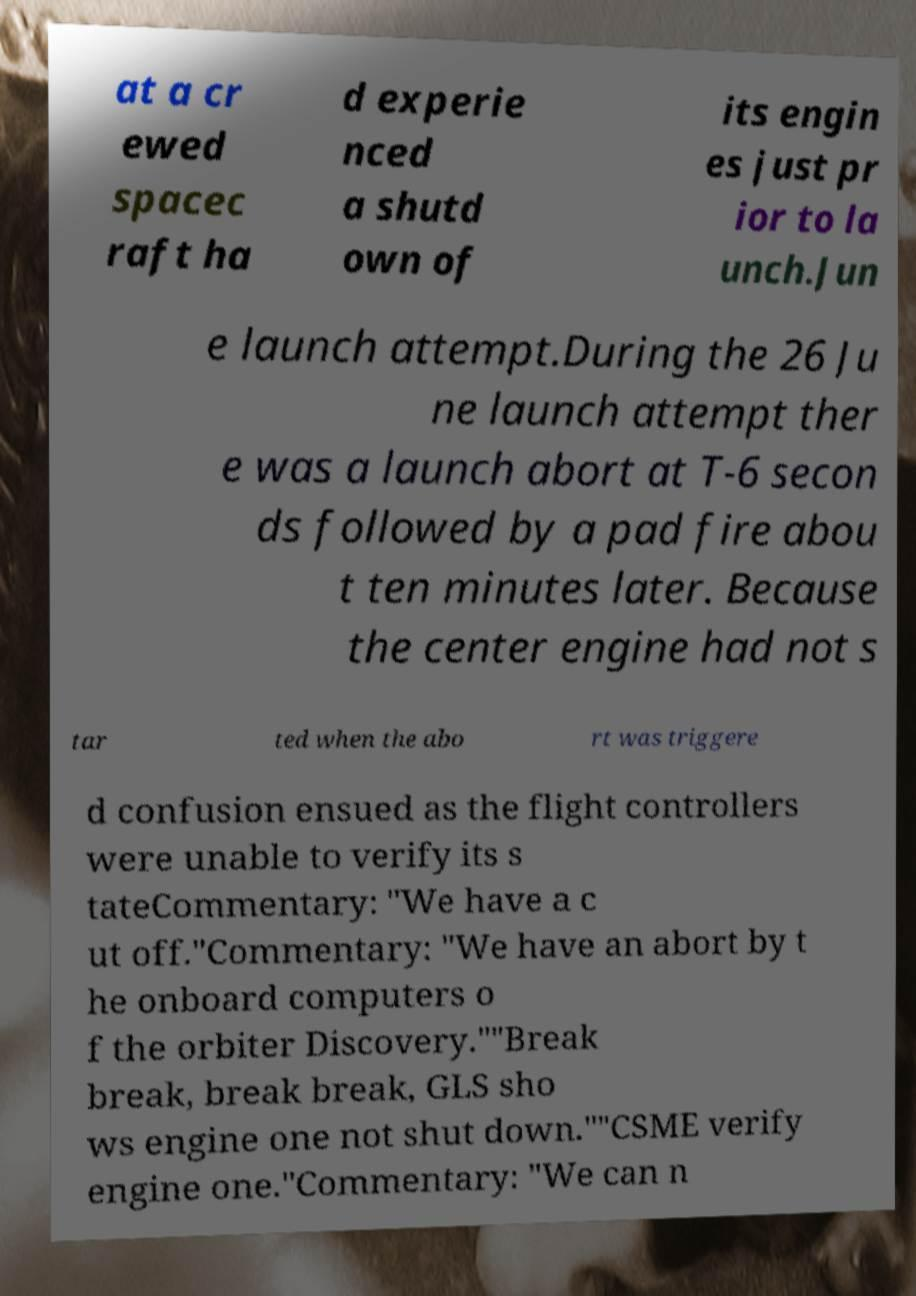What messages or text are displayed in this image? I need them in a readable, typed format. at a cr ewed spacec raft ha d experie nced a shutd own of its engin es just pr ior to la unch.Jun e launch attempt.During the 26 Ju ne launch attempt ther e was a launch abort at T-6 secon ds followed by a pad fire abou t ten minutes later. Because the center engine had not s tar ted when the abo rt was triggere d confusion ensued as the flight controllers were unable to verify its s tateCommentary: "We have a c ut off."Commentary: "We have an abort by t he onboard computers o f the orbiter Discovery.""Break break, break break, GLS sho ws engine one not shut down.""CSME verify engine one."Commentary: "We can n 